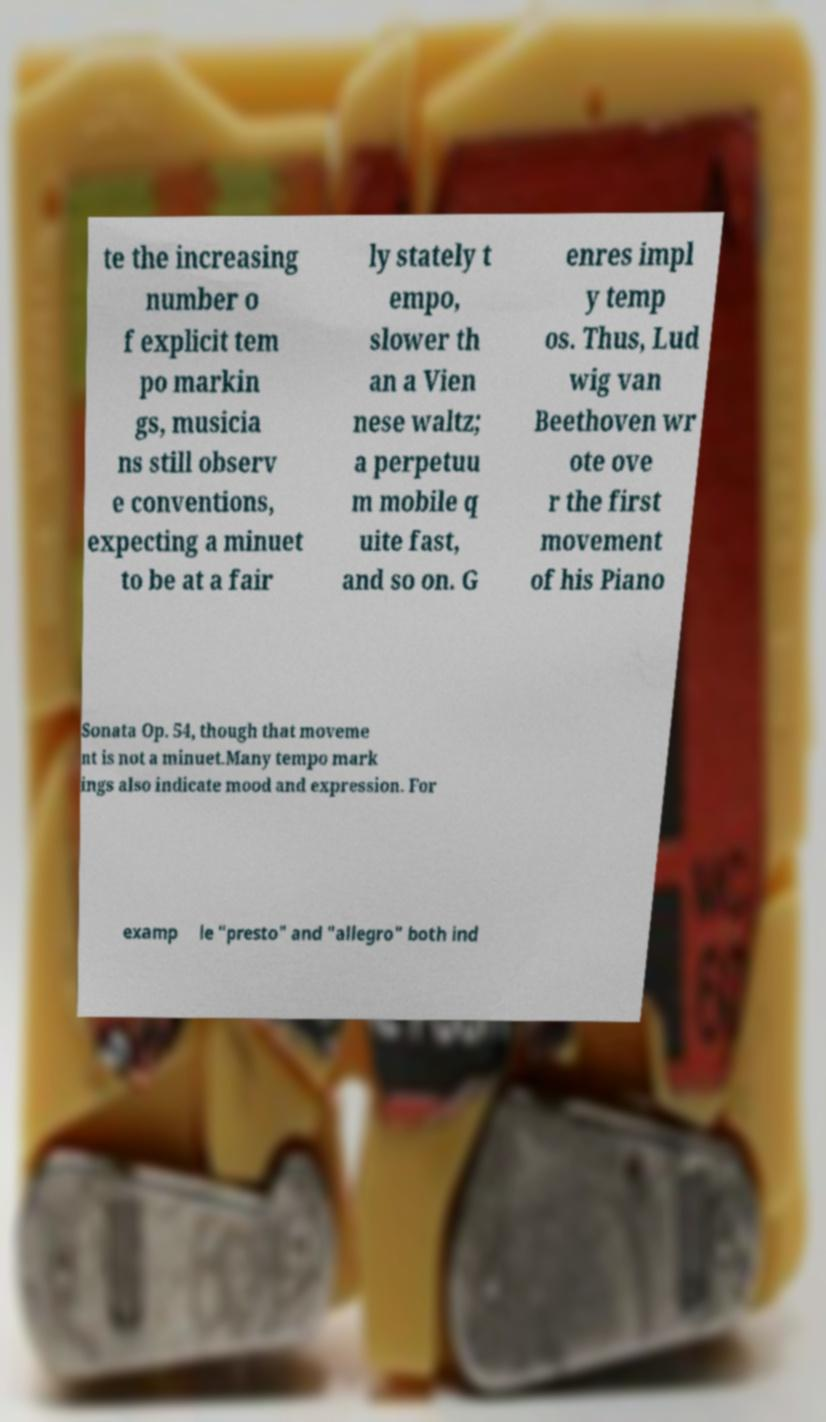Could you extract and type out the text from this image? te the increasing number o f explicit tem po markin gs, musicia ns still observ e conventions, expecting a minuet to be at a fair ly stately t empo, slower th an a Vien nese waltz; a perpetuu m mobile q uite fast, and so on. G enres impl y temp os. Thus, Lud wig van Beethoven wr ote ove r the first movement of his Piano Sonata Op. 54, though that moveme nt is not a minuet.Many tempo mark ings also indicate mood and expression. For examp le "presto" and "allegro" both ind 